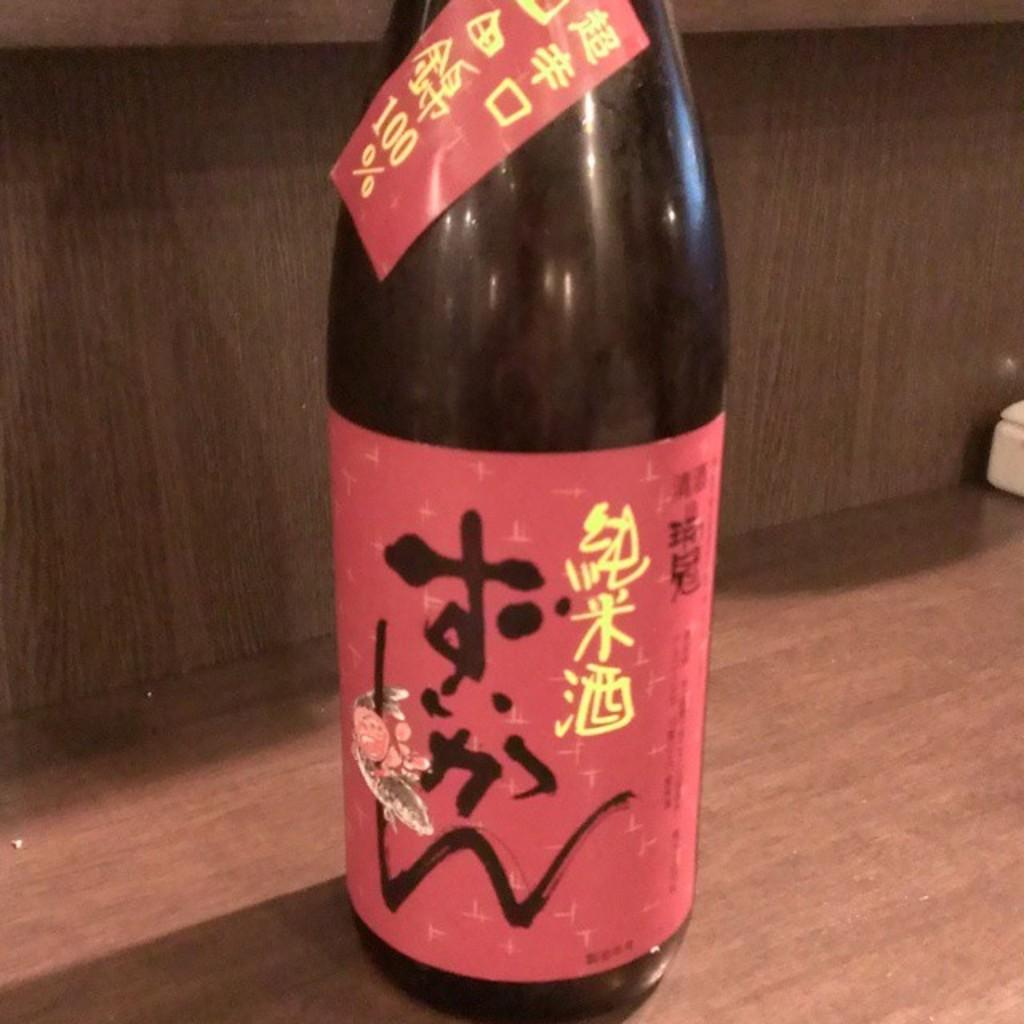<image>
Relay a brief, clear account of the picture shown. A black bottle of alcohol with a red label and japanese characters on it. 